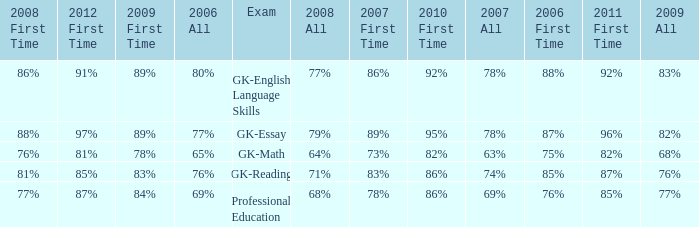What is the percentage for first time in 2012 when it was 82% for all in 2009? 97%. 